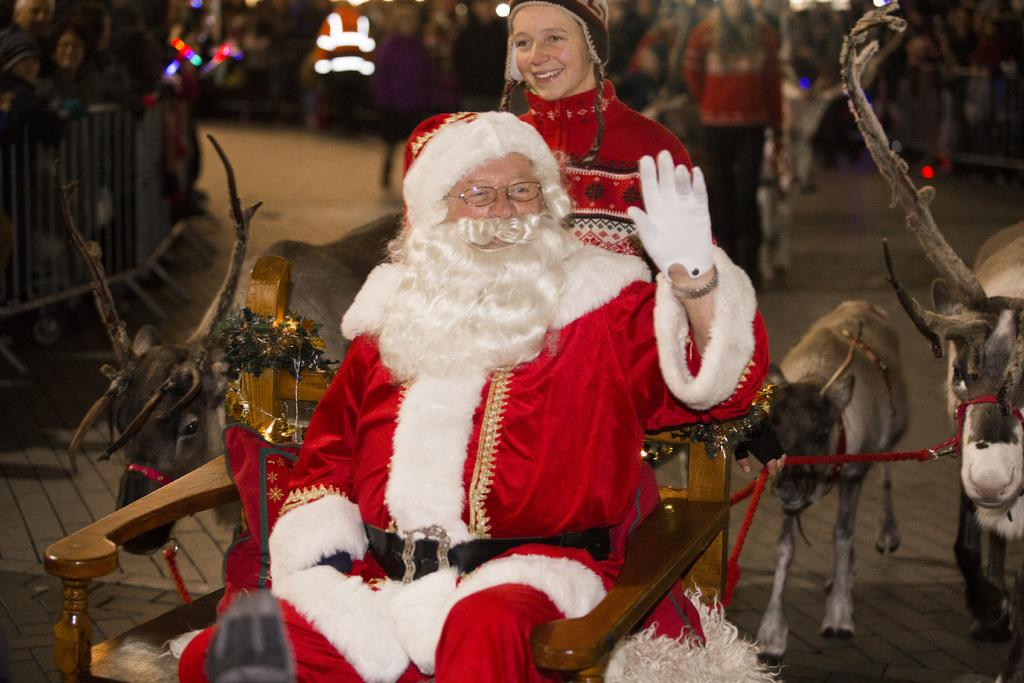What is the main subject of the image? There is a man in the image. What is the man doing in the image? The man is sitting on a chair. What is the man wearing in the image? The man is wearing a Santa Cruz costume. What can be seen in the background of the image? There are many people in the background of the image. What animals are present in the image? There are deer in the image. What object can be seen in the image that might be used for crowd control or safety? There is a barricade in the image. How many cherries can be seen in the man's hand in the image? There are no cherries present in the image; the man is wearing a Santa Cruz costume. What type of grip does the man have on the copy of the book in the image? There is no book present in the image, and the man is wearing a costume, not holding anything in his hand. 